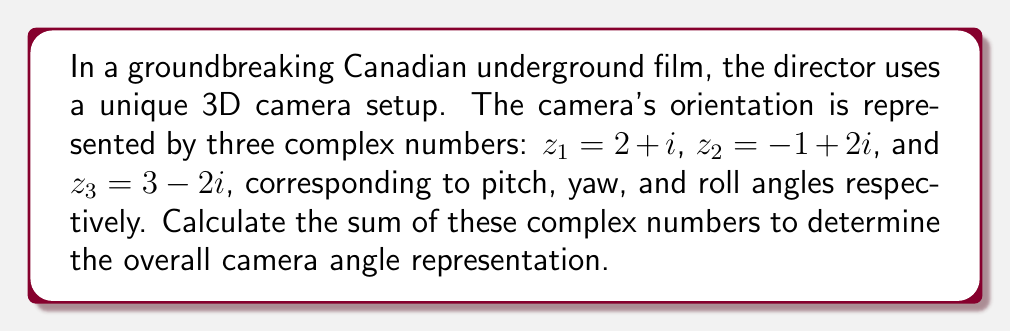What is the answer to this math problem? To find the sum of complex numbers, we add their real and imaginary parts separately:

1) First, let's identify the real and imaginary parts of each complex number:
   $z_1 = 2 + i$
   $z_2 = -1 + 2i$
   $z_3 = 3 - 2i$

2) Now, let's add the real parts:
   Real part sum = $2 + (-1) + 3 = 4$

3) Next, let's add the imaginary parts:
   Imaginary part sum = $1 + 2 + (-2) = 1$

4) The sum of the complex numbers is the combination of the real and imaginary sums:
   $z_{sum} = 4 + i$

This complex number represents the overall camera angle in 3D space, where 4 is the real component and 1 is the coefficient of the imaginary component.
Answer: $4 + i$ 